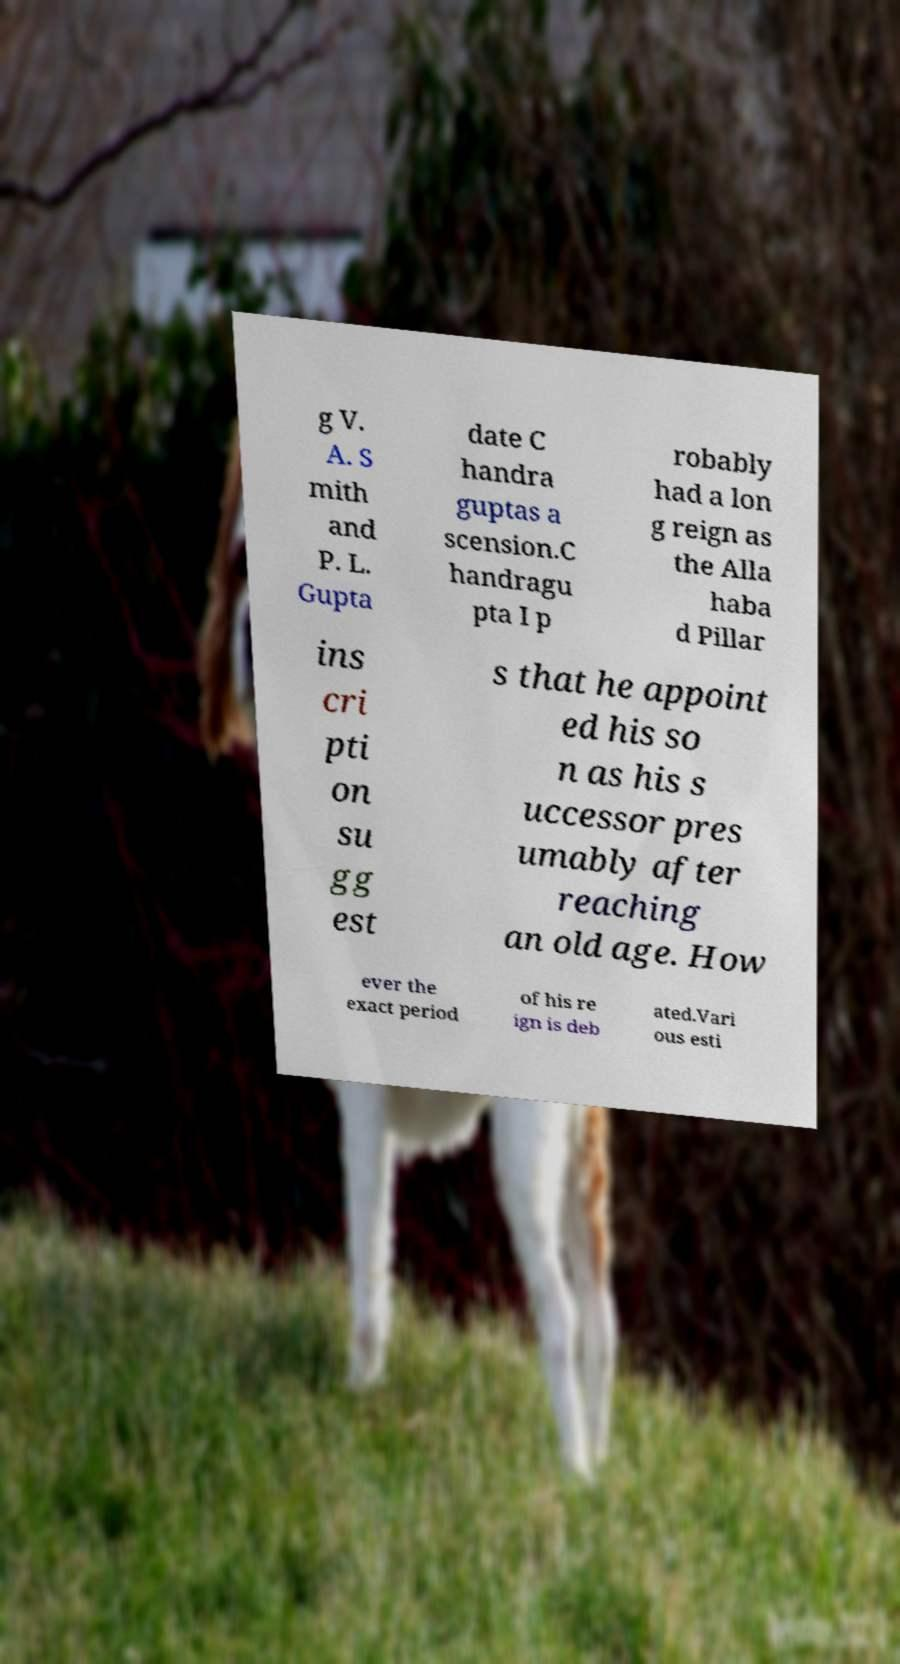Can you read and provide the text displayed in the image?This photo seems to have some interesting text. Can you extract and type it out for me? g V. A. S mith and P. L. Gupta date C handra guptas a scension.C handragu pta I p robably had a lon g reign as the Alla haba d Pillar ins cri pti on su gg est s that he appoint ed his so n as his s uccessor pres umably after reaching an old age. How ever the exact period of his re ign is deb ated.Vari ous esti 